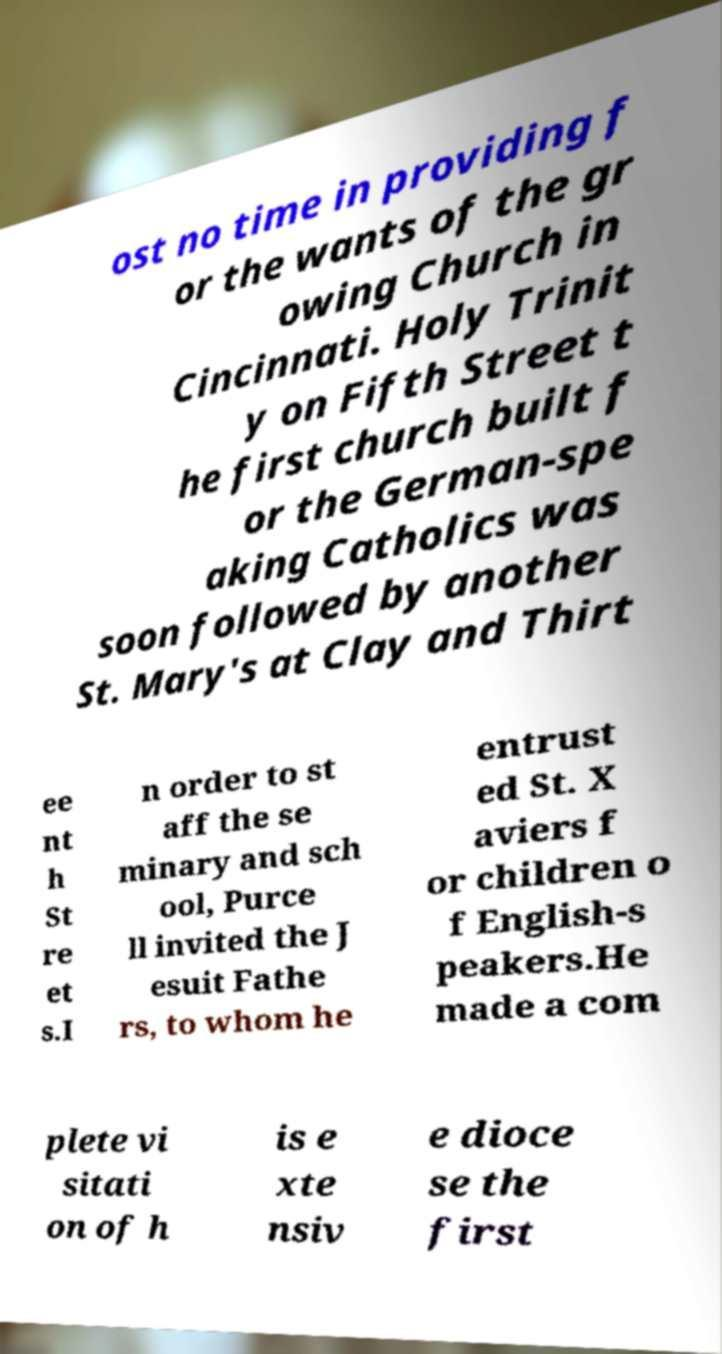Please identify and transcribe the text found in this image. ost no time in providing f or the wants of the gr owing Church in Cincinnati. Holy Trinit y on Fifth Street t he first church built f or the German-spe aking Catholics was soon followed by another St. Mary's at Clay and Thirt ee nt h St re et s.I n order to st aff the se minary and sch ool, Purce ll invited the J esuit Fathe rs, to whom he entrust ed St. X aviers f or children o f English-s peakers.He made a com plete vi sitati on of h is e xte nsiv e dioce se the first 